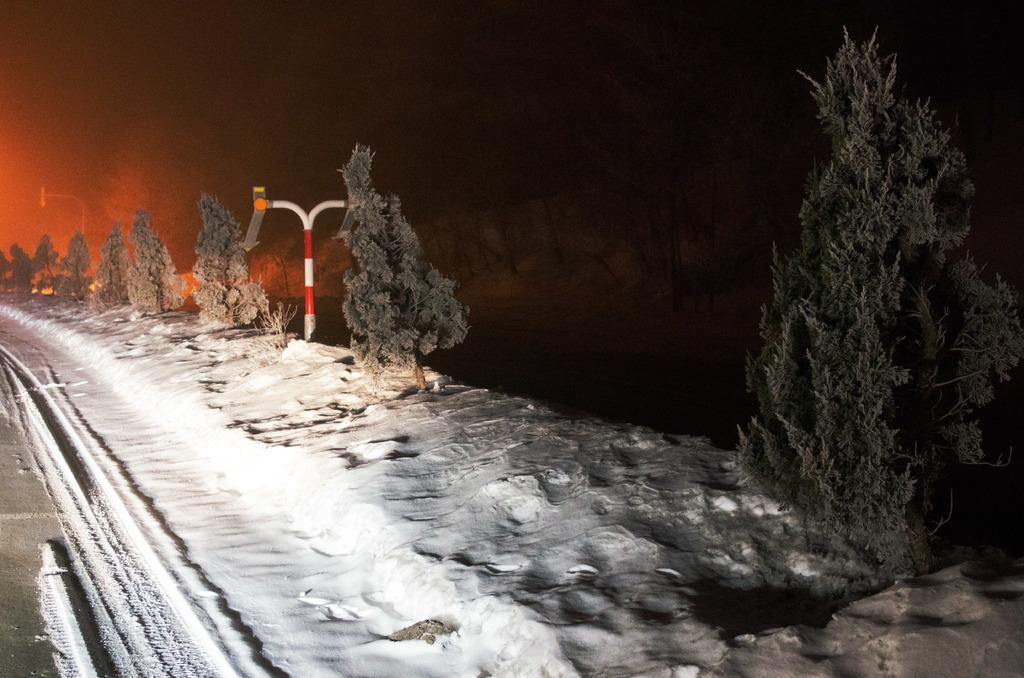Can you describe this image briefly? In this picture we can see snow, trees, board and poles. In the background of the image it is dark. 